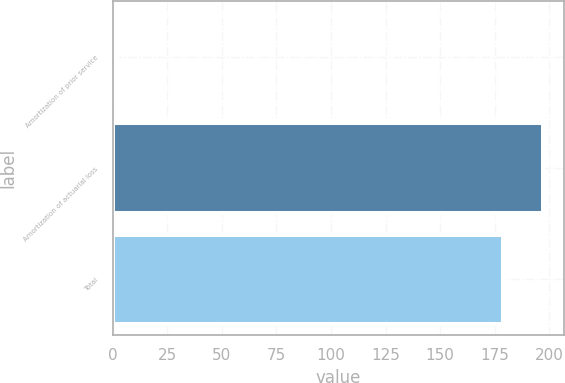Convert chart to OTSL. <chart><loc_0><loc_0><loc_500><loc_500><bar_chart><fcel>Amortization of prior service<fcel>Amortization of actuarial loss<fcel>Total<nl><fcel>2<fcel>196.9<fcel>179<nl></chart> 